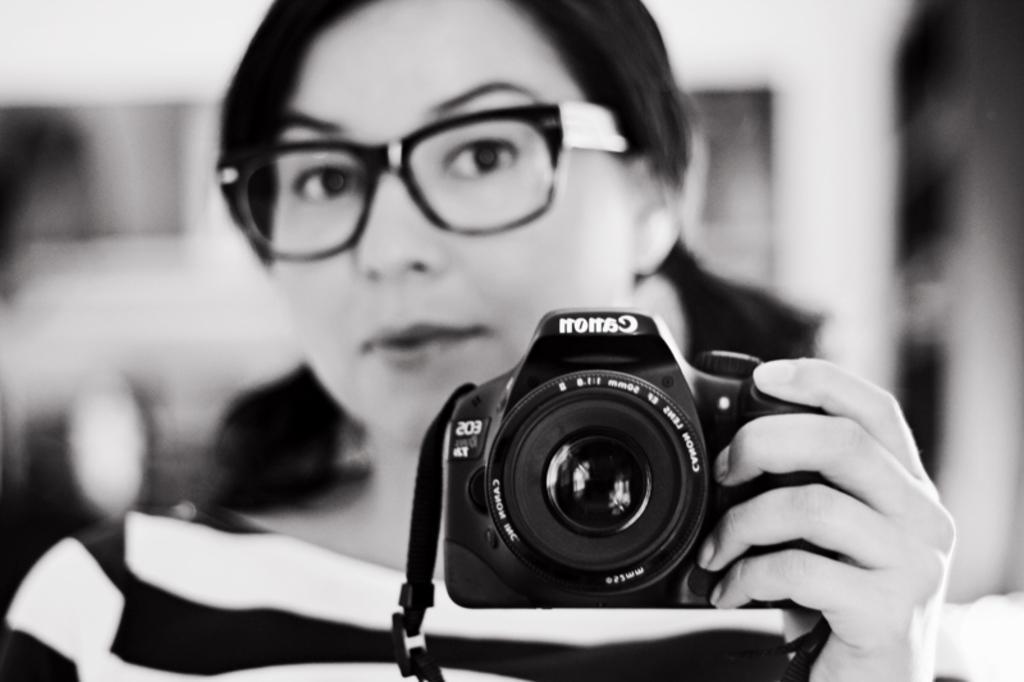Describe this image in one or two sentences. This is the picture of a lady in black and white shirt and having spectacles is holding the camera and taking the picture in the mirror. 